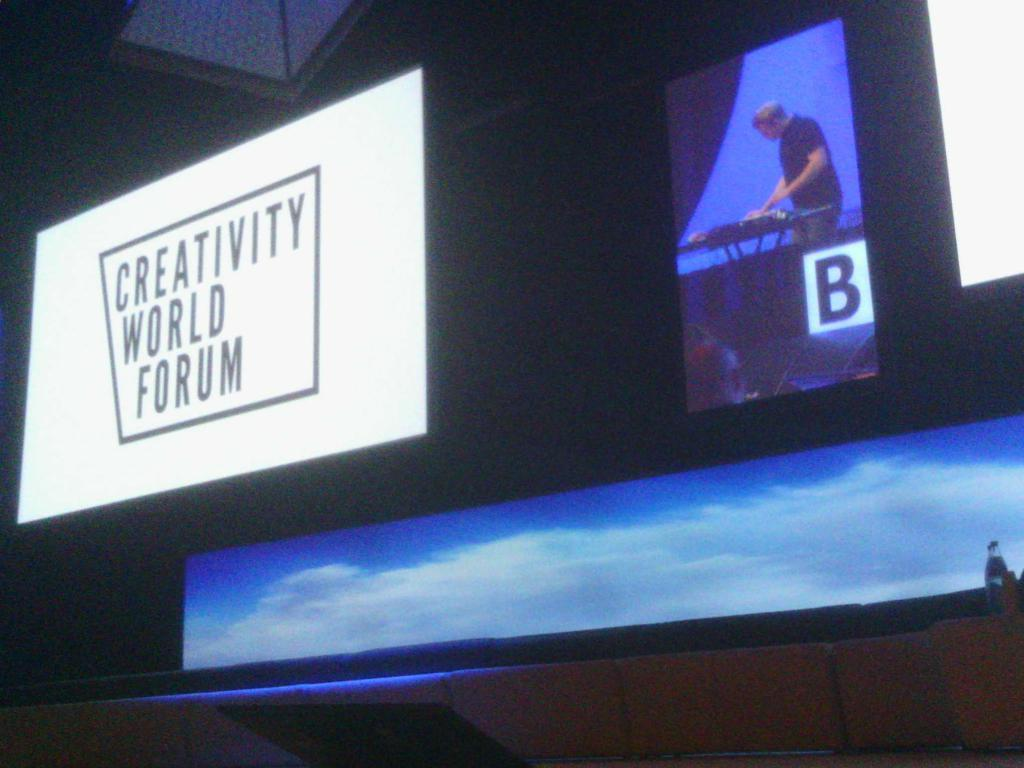<image>
Describe the image concisely. A large screen can be seen with the words Creativity World Forum on it. 